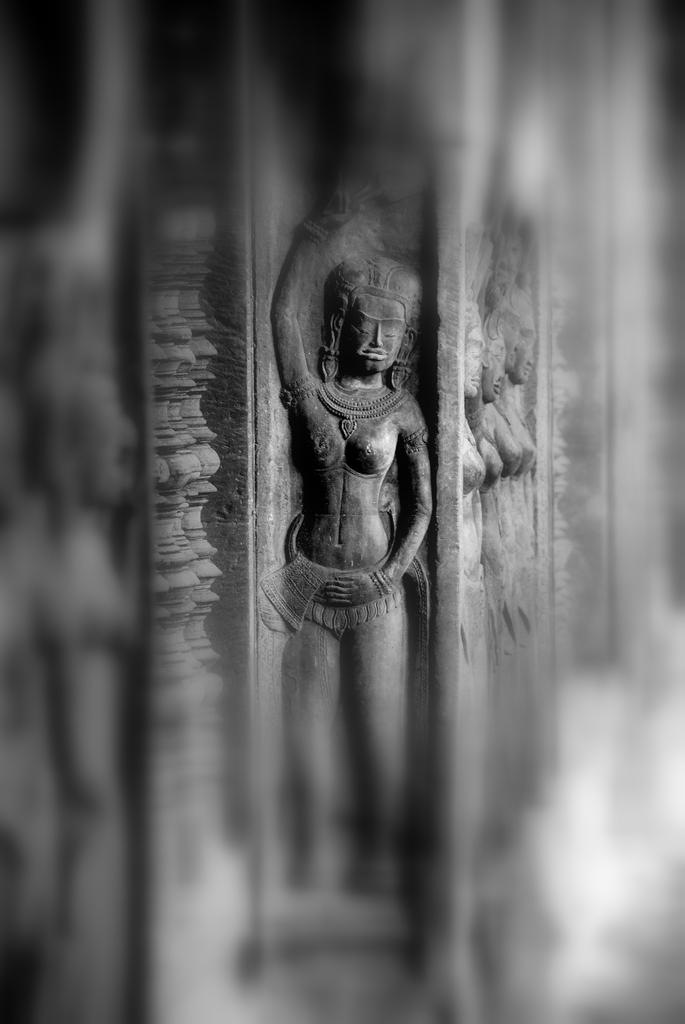What can be seen in the image? There are sculptures in the image. Where are the sculptures located? The sculptures are on a rock. Can you describe the background of the image? The background of the image is blurred. How many ducks are sitting on the sculptures in the image? There are no ducks present in the image; it only features sculptures on a rock. 